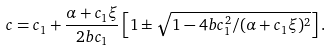<formula> <loc_0><loc_0><loc_500><loc_500>c = c _ { 1 } + \frac { \alpha + c _ { 1 } \xi } { 2 b c _ { 1 } } \left [ 1 \pm \sqrt { 1 - { 4 b c _ { 1 } ^ { 2 } } / { ( \alpha + c _ { 1 } \xi ) ^ { 2 } } } \right ] .</formula> 